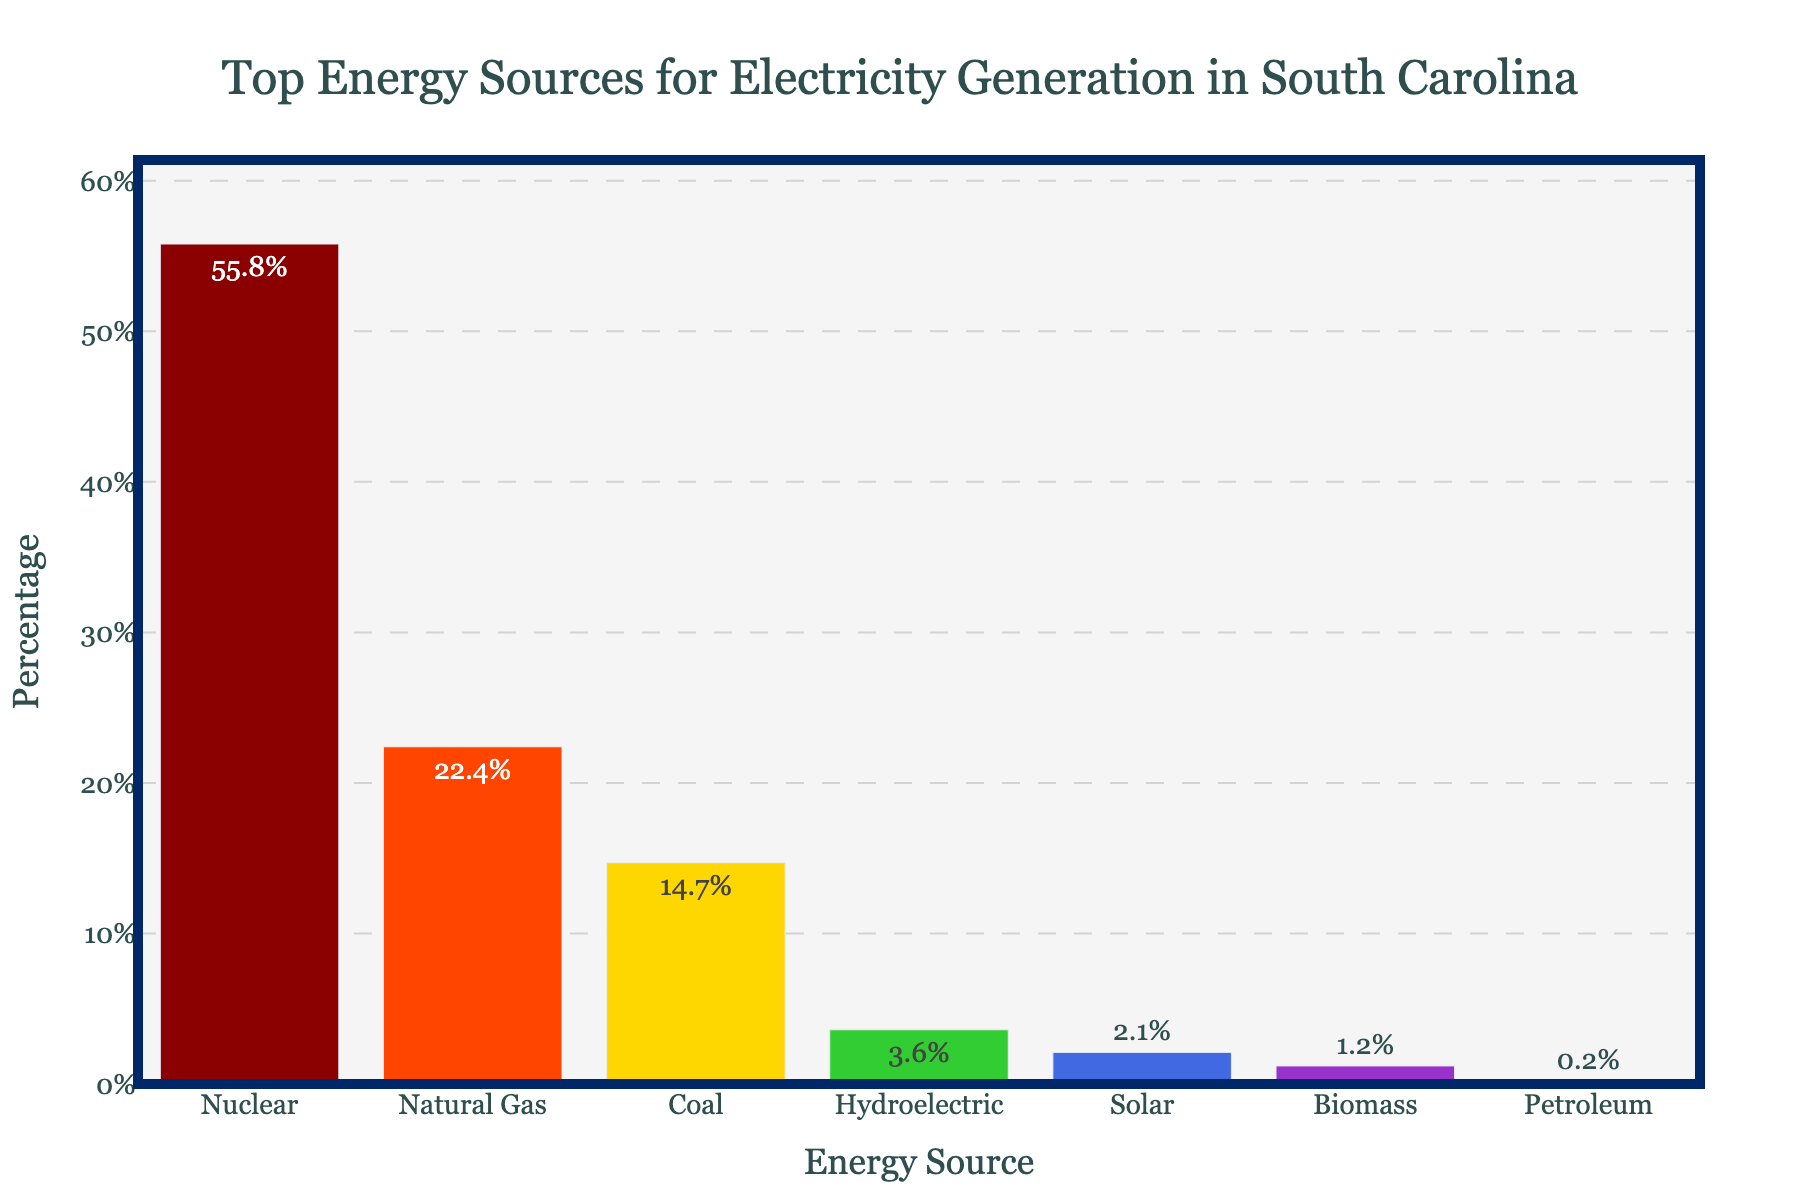Which energy source generates the highest percentage of electricity in South Carolina? The bar representing 'Nuclear' is the tallest, indicating it generates the highest percentage.
Answer: Nuclear How much more electricity is generated by natural gas compared to coal? The percentage for natural gas is 22.4%, and for coal, it is 14.7%. Subtracting the two gives 22.4% - 14.7% = 7.7%.
Answer: 7.7% What is the combined percentage of renewable energy sources used for electricity generation? The renewable energy sources listed are hydroelectric (3.6%), solar (2.1%), and biomass (1.2%). Adding these percentages gives 3.6% + 2.1% + 1.2% = 6.9%.
Answer: 6.9% Which energy source has a lower percentage than biomass but higher than petroleum? The percentage for biomass is 1.2%, and for petroleum, it is 0.2%. Solar, at 2.1%, fits the requirement as it is higher than petroleum but lower than biomass.
Answer: Solar What is the median percentage of electricity generation among all energy sources? Arrange the percentages in ascending order: 0.2%, 1.2%, 2.1%, 3.6%, 14.7%, 22.4%, 55.8%. The middle value (the fourth one) is 3.6%.
Answer: 3.6% Which energy source depicted in the chart uses the color green for its bar? The green color in the bars corresponds to the 'Hydroelectric' energy source.
Answer: Hydroelectric What is the percentage difference between the largest and smallest energy sources? The largest percentage is for Nuclear (55.8%) and the smallest is for Petroleum (0.2%). The difference is 55.8% - 0.2% = 55.6%.
Answer: 55.6% Among non-renewable energy sources, which one contributes the least to electricity generation? The non-renewable energy sources listed are nuclear, natural gas, coal, and petroleum. Petroleum has the smallest percentage at 0.2%.
Answer: Petroleum Which energy source has the third highest percentage for electricity generation in South Carolina? The third highest percentage value corresponds to 'Coal', which is 14.7%.
Answer: Coal 